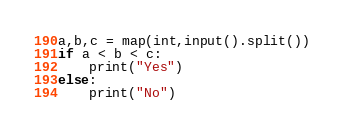<code> <loc_0><loc_0><loc_500><loc_500><_Python_>a,b,c = map(int,input().split())
if a < b < c:
    print("Yes")
else:
    print("No")
</code> 